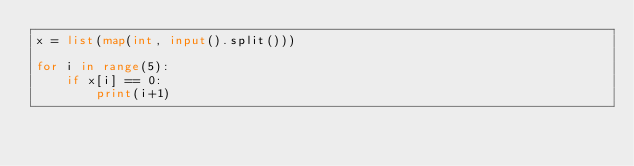<code> <loc_0><loc_0><loc_500><loc_500><_Python_>x = list(map(int, input().split()))

for i in range(5):
    if x[i] == 0:
        print(i+1)</code> 